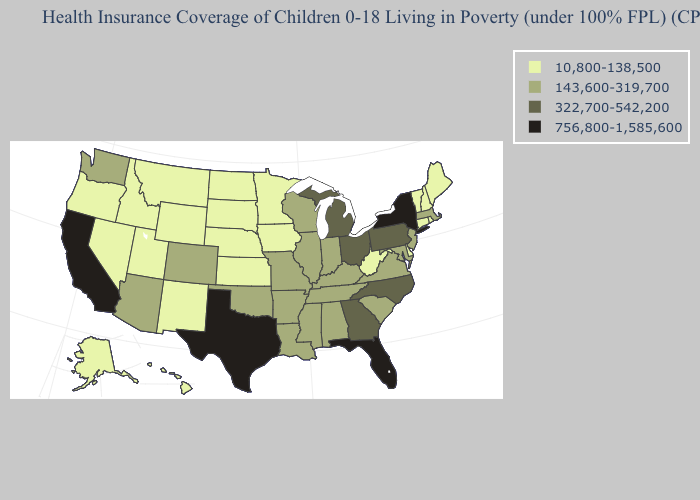Among the states that border South Carolina , which have the lowest value?
Quick response, please. Georgia, North Carolina. Does Minnesota have the same value as California?
Keep it brief. No. What is the value of Colorado?
Give a very brief answer. 143,600-319,700. What is the value of Oregon?
Write a very short answer. 10,800-138,500. What is the value of Utah?
Concise answer only. 10,800-138,500. Does Wisconsin have the highest value in the MidWest?
Give a very brief answer. No. Name the states that have a value in the range 143,600-319,700?
Answer briefly. Alabama, Arizona, Arkansas, Colorado, Illinois, Indiana, Kentucky, Louisiana, Maryland, Massachusetts, Mississippi, Missouri, New Jersey, Oklahoma, South Carolina, Tennessee, Virginia, Washington, Wisconsin. What is the value of Illinois?
Concise answer only. 143,600-319,700. Name the states that have a value in the range 756,800-1,585,600?
Concise answer only. California, Florida, New York, Texas. Does North Carolina have a lower value than New York?
Concise answer only. Yes. What is the lowest value in the USA?
Write a very short answer. 10,800-138,500. What is the value of North Dakota?
Short answer required. 10,800-138,500. How many symbols are there in the legend?
Answer briefly. 4. Which states have the lowest value in the USA?
Quick response, please. Alaska, Connecticut, Delaware, Hawaii, Idaho, Iowa, Kansas, Maine, Minnesota, Montana, Nebraska, Nevada, New Hampshire, New Mexico, North Dakota, Oregon, Rhode Island, South Dakota, Utah, Vermont, West Virginia, Wyoming. What is the value of Maine?
Answer briefly. 10,800-138,500. 